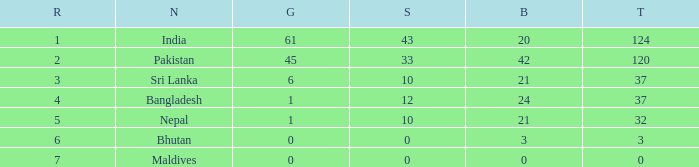How much Rank has a Bronze of 21, and a Silver larger than 10? 0.0. 